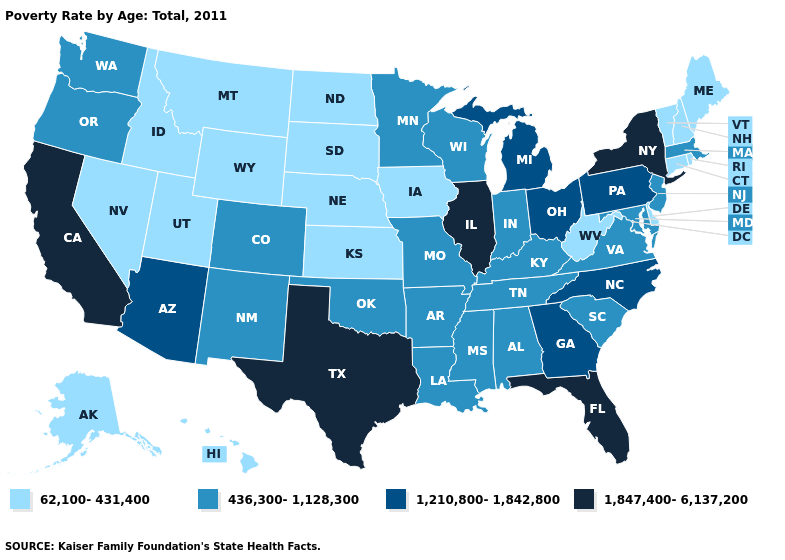What is the highest value in the USA?
Be succinct. 1,847,400-6,137,200. Name the states that have a value in the range 436,300-1,128,300?
Give a very brief answer. Alabama, Arkansas, Colorado, Indiana, Kentucky, Louisiana, Maryland, Massachusetts, Minnesota, Mississippi, Missouri, New Jersey, New Mexico, Oklahoma, Oregon, South Carolina, Tennessee, Virginia, Washington, Wisconsin. Name the states that have a value in the range 436,300-1,128,300?
Short answer required. Alabama, Arkansas, Colorado, Indiana, Kentucky, Louisiana, Maryland, Massachusetts, Minnesota, Mississippi, Missouri, New Jersey, New Mexico, Oklahoma, Oregon, South Carolina, Tennessee, Virginia, Washington, Wisconsin. Name the states that have a value in the range 1,847,400-6,137,200?
Be succinct. California, Florida, Illinois, New York, Texas. Does the map have missing data?
Keep it brief. No. What is the value of Maine?
Keep it brief. 62,100-431,400. Which states have the lowest value in the USA?
Be succinct. Alaska, Connecticut, Delaware, Hawaii, Idaho, Iowa, Kansas, Maine, Montana, Nebraska, Nevada, New Hampshire, North Dakota, Rhode Island, South Dakota, Utah, Vermont, West Virginia, Wyoming. Name the states that have a value in the range 1,847,400-6,137,200?
Concise answer only. California, Florida, Illinois, New York, Texas. What is the lowest value in states that border Idaho?
Write a very short answer. 62,100-431,400. Which states have the highest value in the USA?
Be succinct. California, Florida, Illinois, New York, Texas. What is the value of Arizona?
Give a very brief answer. 1,210,800-1,842,800. What is the value of North Dakota?
Answer briefly. 62,100-431,400. Among the states that border Delaware , does Maryland have the highest value?
Short answer required. No. Does Kansas have the lowest value in the MidWest?
Write a very short answer. Yes. Among the states that border Ohio , does Kentucky have the highest value?
Short answer required. No. 